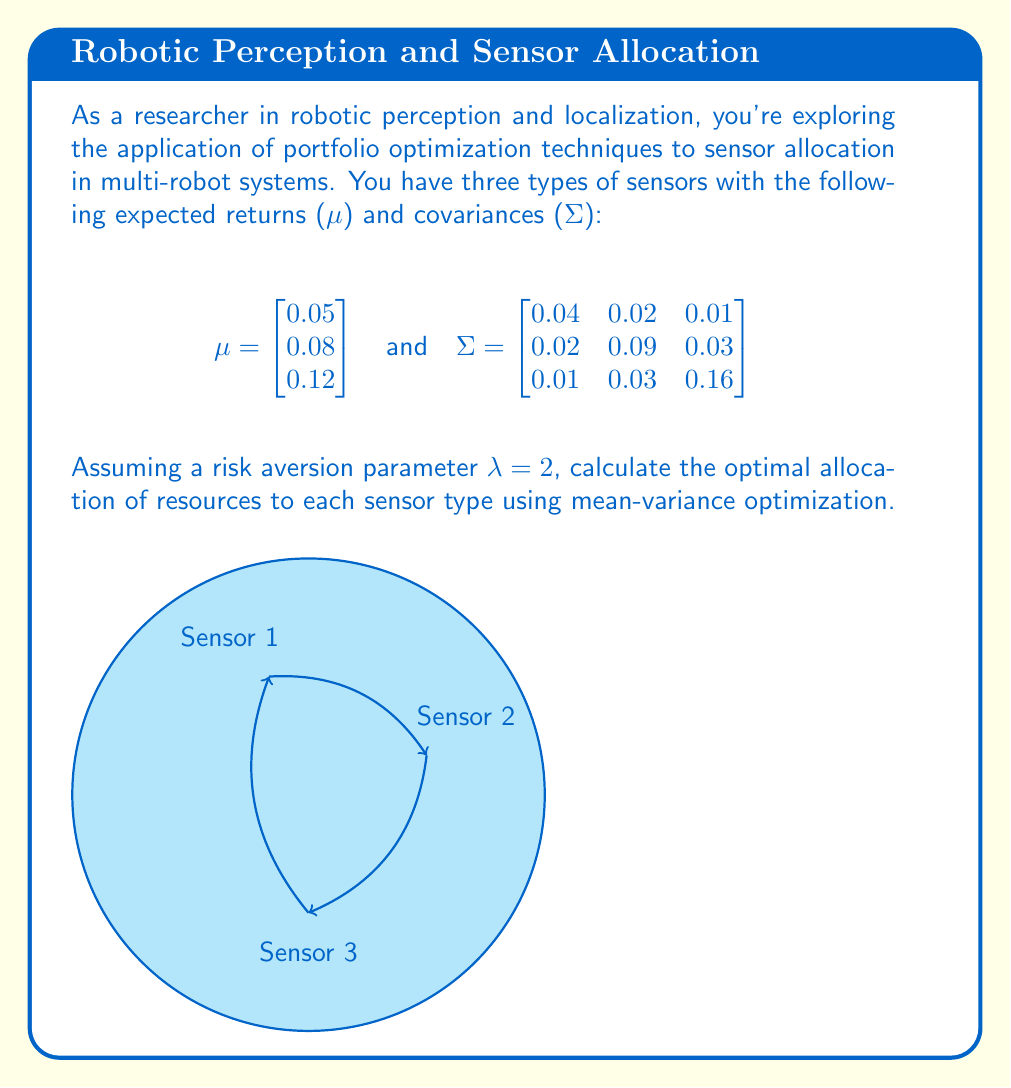Solve this math problem. To solve this problem, we'll use the mean-variance optimization formula:

$$w^* = \frac{1}{\lambda} \Sigma^{-1} \mu$$

Where:
- $w^*$ is the optimal portfolio weights
- $\lambda$ is the risk aversion parameter
- $\Sigma^{-1}$ is the inverse of the covariance matrix
- $\mu$ is the vector of expected returns

Step 1: Calculate $\Sigma^{-1}$
Using a matrix calculator or linear algebra software, we find:

$$\Sigma^{-1} = \begin{bmatrix}
27.7778 & -5.5556 & -0.6944 \\
-5.5556 & 13.8889 & -1.7361 \\
-0.6944 & -1.7361 & 7.2917
\end{bmatrix}$$

Step 2: Multiply $\Sigma^{-1}$ by $\mu$

$$\Sigma^{-1} \mu = \begin{bmatrix}
27.7778 & -5.5556 & -0.6944 \\
-5.5556 & 13.8889 & -1.7361 \\
-0.6944 & -1.7361 & 7.2917
\end{bmatrix} \begin{bmatrix} 0.05 \\ 0.08 \\ 0.12 \end{bmatrix}
= \begin{bmatrix} 0.9722 \\ 0.6944 \\ 0.7639 \end{bmatrix}$$

Step 3: Divide by $\lambda$ to get $w^*$

$$w^* = \frac{1}{\lambda} \Sigma^{-1} \mu = \frac{1}{2} \begin{bmatrix} 0.9722 \\ 0.6944 \\ 0.7639 \end{bmatrix} = \begin{bmatrix} 0.4861 \\ 0.3472 \\ 0.3819 \end{bmatrix}$$

Step 4: Normalize the weights to ensure they sum to 1

$$\text{Total} = 0.4861 + 0.3472 + 0.3819 = 1.2152$$

$$w^*_{\text{normalized}} = \begin{bmatrix} 
0.4861 / 1.2152 \\
0.3472 / 1.2152 \\
0.3819 / 1.2152
\end{bmatrix} = \begin{bmatrix} 
0.4000 \\
0.2857 \\
0.3143
\end{bmatrix}$$
Answer: $w^* = (0.4000, 0.2857, 0.3143)$ 